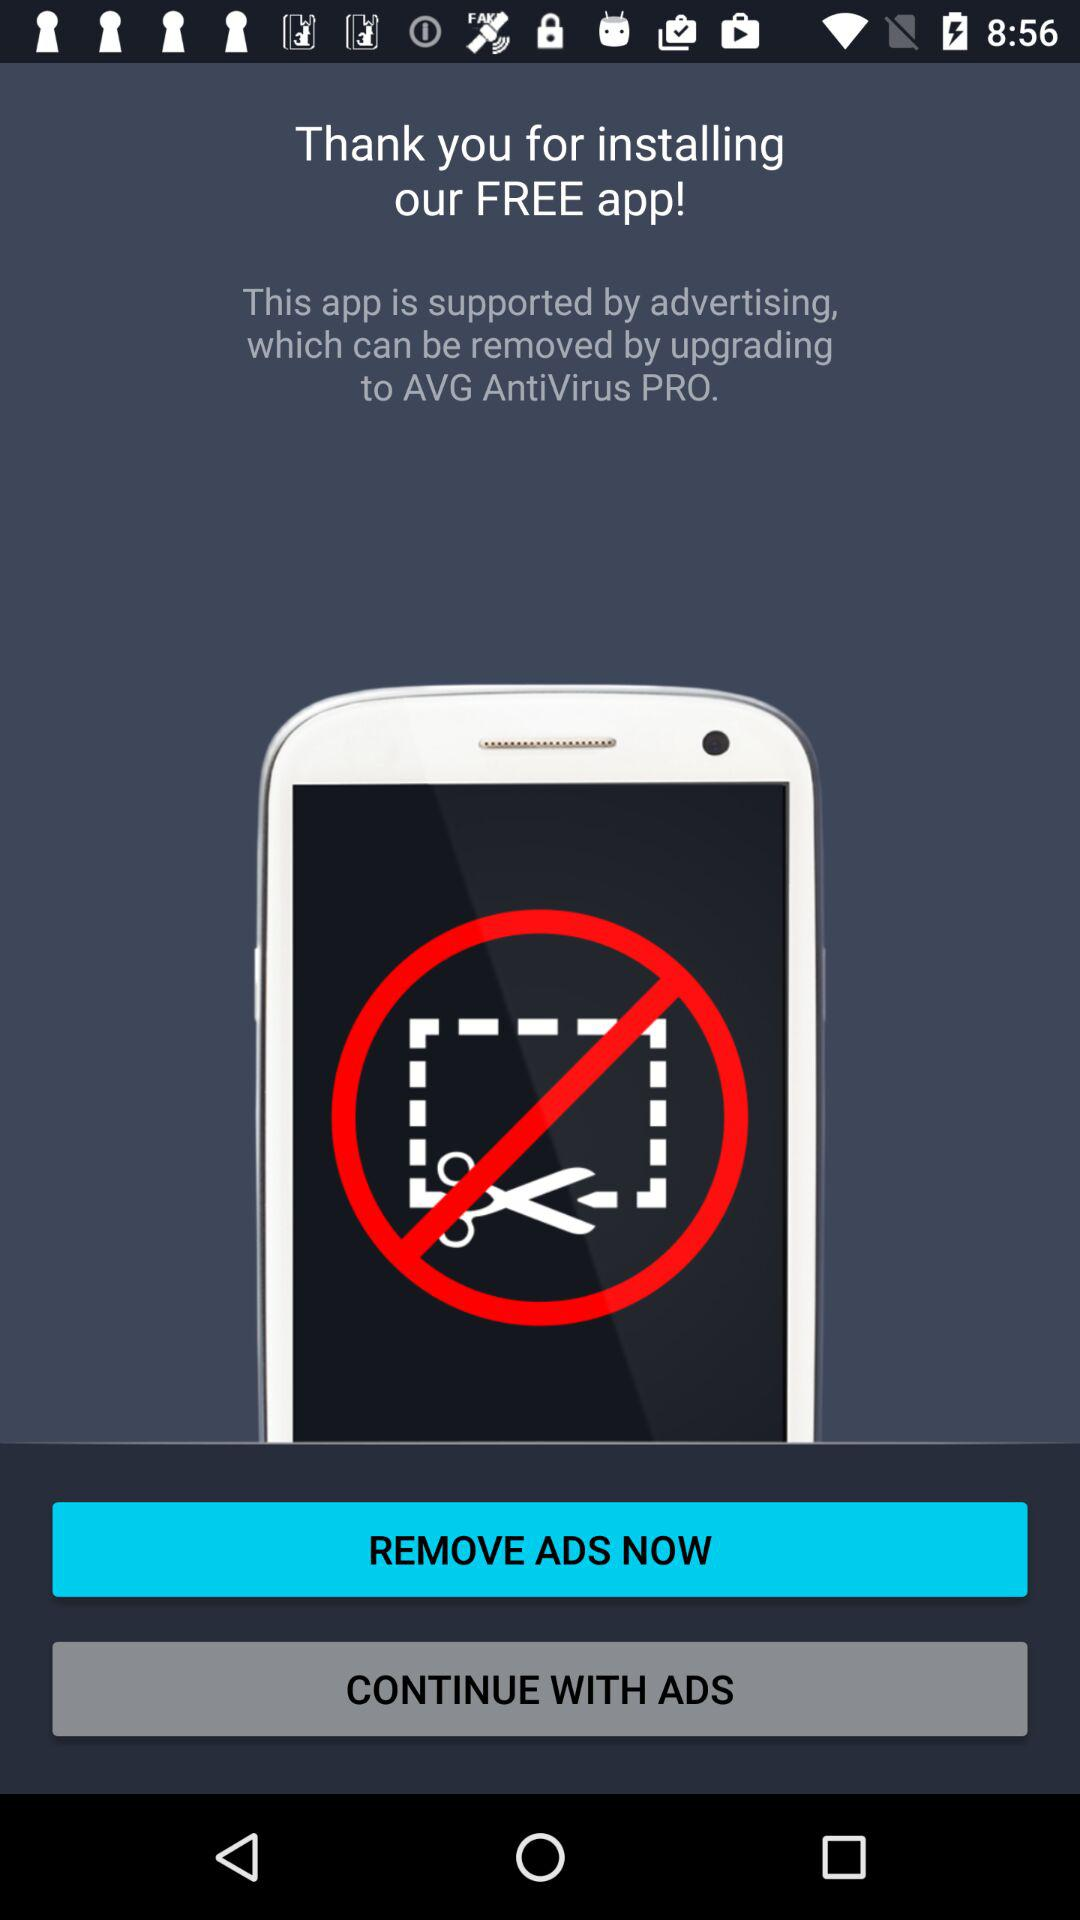What is the name of the application mentioned? The name of the application mentioned is "AVG AntiVirus PRO". 